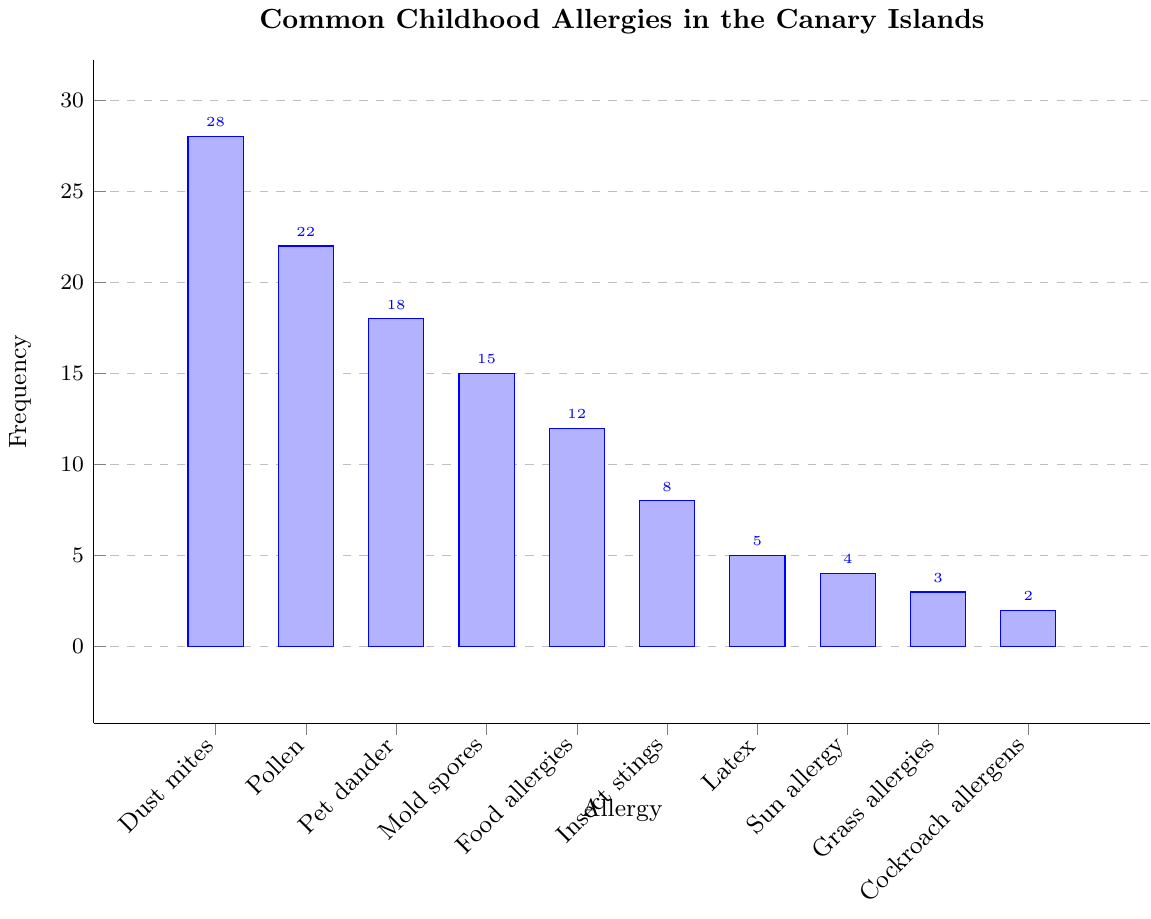Which allergy has the highest frequency? The allergy with the highest frequency can be identified as the tallest bar on the chart. The tallest bar corresponds to Dust mites.
Answer: Dust mites Which allergies have a frequency above 20? To find the allergies with a frequency above 20, we look for bars whose heights extend beyond the 20 mark on the frequency axis. Dust mites and Pollen fulfill this criterion.
Answer: Dust mites, Pollen How many allergies have a frequency below 10? Count the number of bars with heights below the 10 mark on the frequency axis. There are five such bars: Insect stings, Latex, Sun allergy, Grass allergies, and Cockroach allergens.
Answer: 5 What is the combined frequency of Dust mites and Pet dander? Add the frequencies of Dust mites and Pet dander by locating their bars: 28 (Dust mites) + 18 (Pet dander).
Answer: 46 Is the frequency of Food allergies less than Mold spores? Compare the heights of the bars for Food allergies and Mold spores. The bar for Food allergies is shorter than the bar for Mold spores.
Answer: Yes Which allergy has a frequency closest to the median frequency? First, list out the frequencies: 28, 22, 18, 15, 12, 8, 5, 4, 3, 2. The median value of this ordered list is the average of the 5th and 6th values, (12+8)/2 = 10. Food allergies have the closest frequency to 10.
Answer: Food allergies What is the difference in frequency between Pollen and Mold spores? Subtract the frequency of Mold spores from Pollen: 22 (Pollen) - 15 (Mold spores).
Answer: 7 How many allergies have a frequency exactly twice that of Cockroach allergens? Locate the bar for Cockroach allergens (frequency = 2). Twice its frequency is 4. The allergy with a frequency of 4 is Sun allergy.
Answer: 1 Are there more allergies with a frequency higher than 15 or lower than 15? Count the number of bars with frequencies higher than 15 and those lower than 15. Higher than 15: Dust mites, Pollen, Pet dander (3). Lower than 15: Mold spores, Food allergies, Insect stings, Latex, Sun allergy, Grass allergies, Cockroach allergens (7). There are more allergies with a frequency lower than 15.
Answer: Lower than 15 